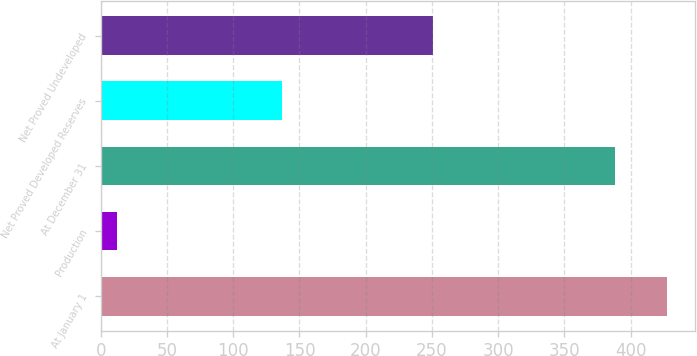<chart> <loc_0><loc_0><loc_500><loc_500><bar_chart><fcel>At January 1<fcel>Production<fcel>At December 31<fcel>Net Proved Developed Reserves<fcel>Net Proved Undeveloped<nl><fcel>427.2<fcel>12<fcel>388<fcel>137<fcel>251<nl></chart> 